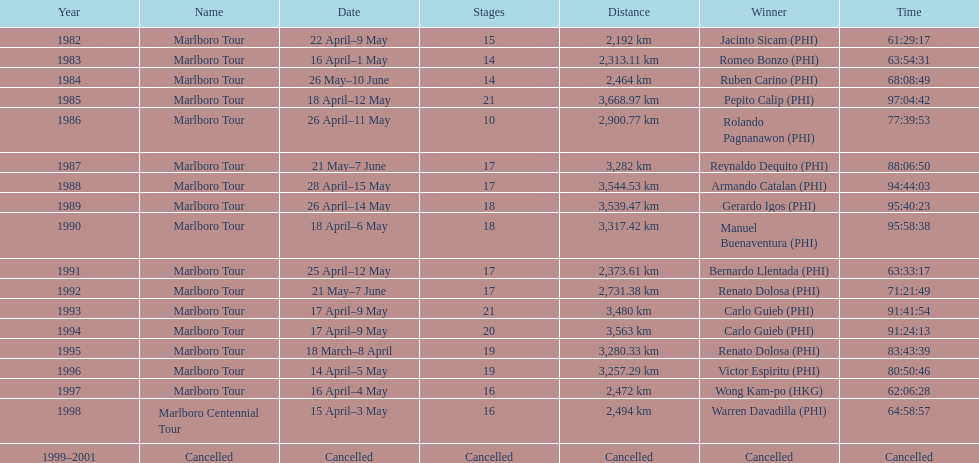How long did it take warren davadilla to complete the 1998 marlboro centennial tour? 64:58:57. 